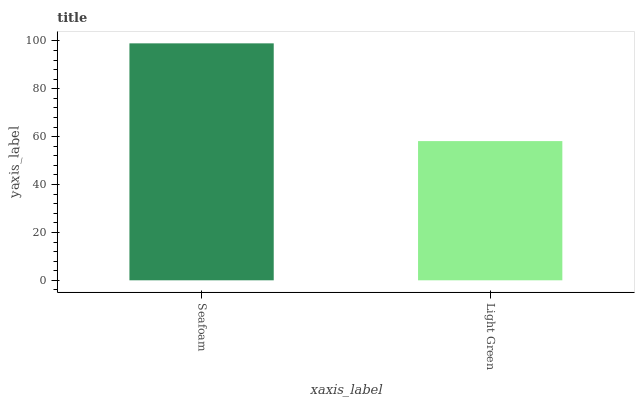Is Light Green the minimum?
Answer yes or no. Yes. Is Seafoam the maximum?
Answer yes or no. Yes. Is Light Green the maximum?
Answer yes or no. No. Is Seafoam greater than Light Green?
Answer yes or no. Yes. Is Light Green less than Seafoam?
Answer yes or no. Yes. Is Light Green greater than Seafoam?
Answer yes or no. No. Is Seafoam less than Light Green?
Answer yes or no. No. Is Seafoam the high median?
Answer yes or no. Yes. Is Light Green the low median?
Answer yes or no. Yes. Is Light Green the high median?
Answer yes or no. No. Is Seafoam the low median?
Answer yes or no. No. 